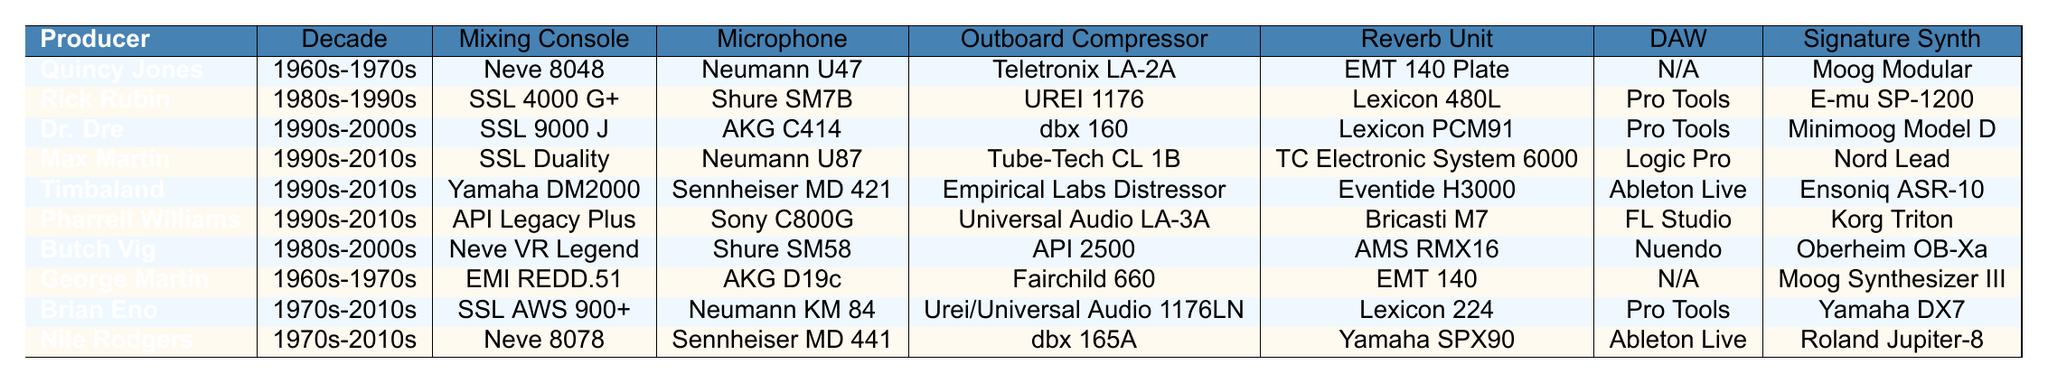What mixing console did Rick Rubin use? According to the table, Rick Rubin's mixing console is listed as SSL 4000 G+.
Answer: SSL 4000 G+ Which producer used the Neumann U87 microphone? The table shows that Max Martin is the producer who used the Neumann U87 microphone.
Answer: Max Martin Did any producer use Pro Tools as their DAW? Yes, the table indicates that both Rick Rubin, Dr. Dre, Max Martin, and Brian Eno used Pro Tools.
Answer: Yes What is the signature synth used by Pharrell Williams? Pharrell Williams' signature synth as per the table is the Korg Triton.
Answer: Korg Triton Comparing the mixing consoles, how many different types were used in the 1990s? In the table, the mixing consoles used by producers in the 1990s include SSL 9000 J, SSL Duality, Yamaha DM2000, API Legacy Plus. This results in a total of four distinct mixing consoles.
Answer: 4 Which producer from the 1960s-1970s used the Fairchild 660 outboard compressor? The table shows that George Martin used the Fairchild 660 compressor during the 1960s-1970s.
Answer: George Martin What type of reverb unit did Nile Rodgers use? The reverb unit listed for Nile Rodgers is the Yamaha SPX90 according to the table.
Answer: Yamaha SPX90 Which microphones were used by producers using SSL mixing consoles? The table specifies that Rick Rubin used the Shure SM7B and Dr. Dre used the AKG C414, both of which correspond with producers who used SSL mixing consoles.
Answer: Shure SM7B and AKG C414 How many producers used Neumann microphones? Examining the table, Quincy Jones (Neumann U47), Max Martin (Neumann U87), Brian Eno (Neumann KM 84), and Nile Rodgers (Sennheiser MD 441 which is not Neumann). Thus, there are three producers who used Neumann microphones.
Answer: 3 What decade saw the use of the Teletronix LA-2A compressor? The table indicates that the Teletronix LA-2A compressor was used in the 1960s-1970s by Quincy Jones.
Answer: 1960s-1970s In which decade did producers primarily use the Yamaha DM2000? According to the table, the Yamaha DM2000 was mainly used during the 1990s to 2010s period by Timbaland.
Answer: 1990s-2010s 